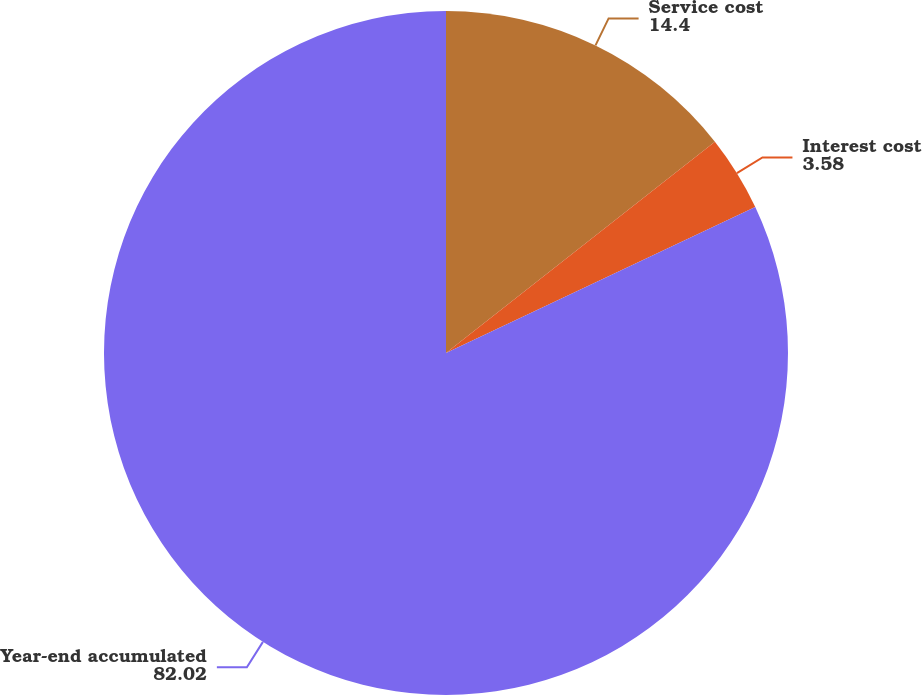Convert chart. <chart><loc_0><loc_0><loc_500><loc_500><pie_chart><fcel>Service cost<fcel>Interest cost<fcel>Year-end accumulated<nl><fcel>14.4%<fcel>3.58%<fcel>82.02%<nl></chart> 